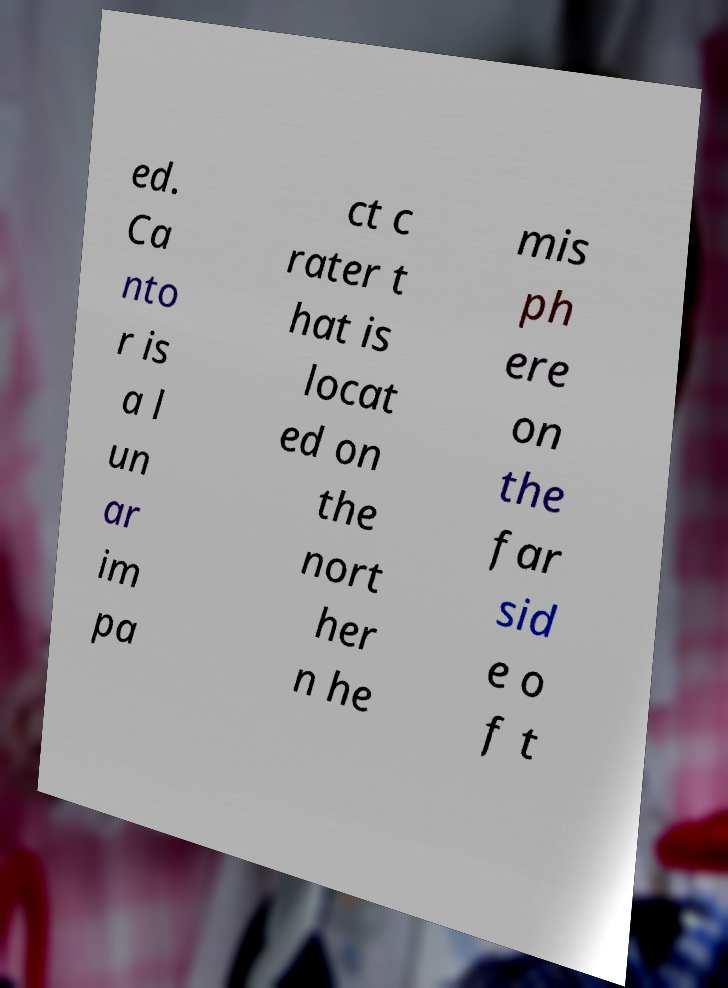There's text embedded in this image that I need extracted. Can you transcribe it verbatim? ed. Ca nto r is a l un ar im pa ct c rater t hat is locat ed on the nort her n he mis ph ere on the far sid e o f t 